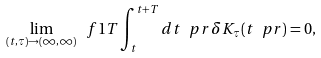Convert formula to latex. <formula><loc_0><loc_0><loc_500><loc_500>\lim _ { ( t , \tau ) \rightarrow ( \infty , \infty ) } \ f { 1 } { T } \int _ { t } ^ { t + T } d t \ p r \, \delta K _ { \tau } ( t \ p r ) = 0 ,</formula> 